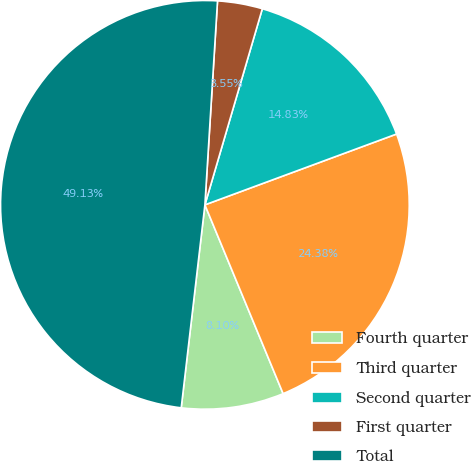Convert chart. <chart><loc_0><loc_0><loc_500><loc_500><pie_chart><fcel>Fourth quarter<fcel>Third quarter<fcel>Second quarter<fcel>First quarter<fcel>Total<nl><fcel>8.1%<fcel>24.38%<fcel>14.83%<fcel>3.55%<fcel>49.13%<nl></chart> 